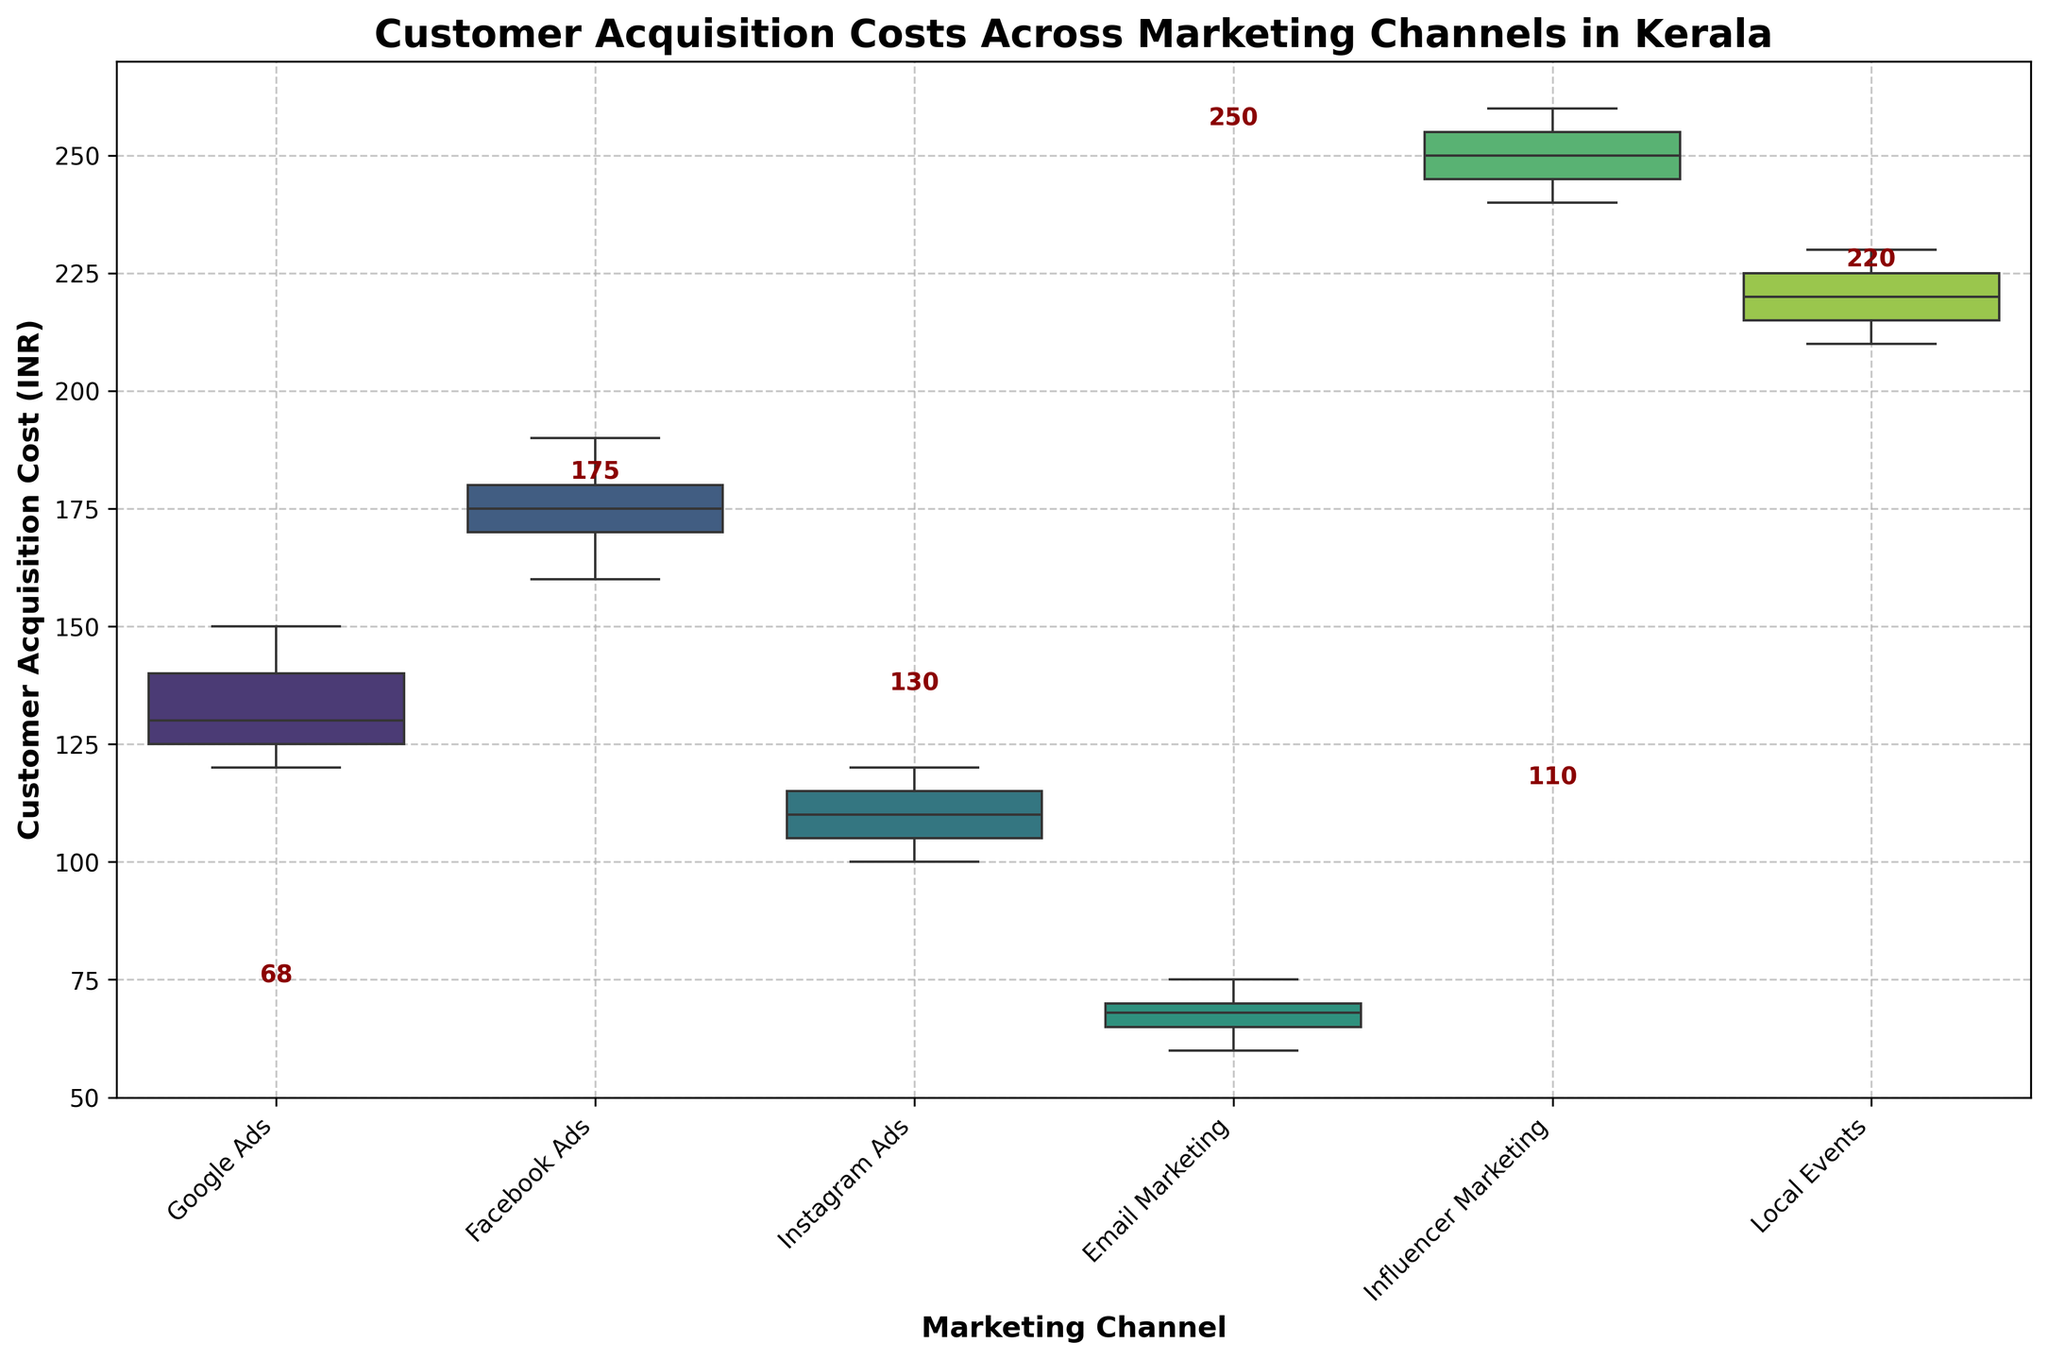Which marketing channel has the highest median customer acquisition cost? To determine the highest median customer acquisition cost, look at the median values displayed on top of each box plot for different marketing channels. Influencer Marketing has the highest median value.
Answer: Influencer Marketing What is the range of customer acquisition costs for Google Ads? The range can be found by looking at the minimum and maximum points of the box plot for Google Ads. The minimum value is 120 INR and the maximum value is 150 INR. Therefore, the range is 150 - 120 = 30 INR.
Answer: 30 INR Which marketing channel has the lowest median customer acquisition cost? The lowest median value is indicated on top of the box plots. Email Marketing has the lowest median value of 68 INR.
Answer: Email Marketing How does the spread of customer acquisition costs compare between Facebook Ads and Local Events? To compare the spread, look at the interquartile range (IQR), indicated by the width of the box in the box plot. Facebook Ads has a somewhat wider box, indicating a larger spread compared to Local Events.
Answer: Facebook Ads has a larger spread What is the interquartile range (IQR) for Instagram Ads? To find the IQR, subtract the lower quartile (25th percentile) from the upper quartile (75th percentile). For Instagram Ads, the lower quartile is 105 INR and the upper quartile is 115 INR. Therefore, the IQR is 115 - 105 = 10 INR.
Answer: 10 INR What is the median customer acquisition cost for Local Events, and how does it compare to that of Facebook Ads? The median values are displayed on top of the box plots. Local Events have a median value of 220 INR, and Facebook Ads have a median value of 180 INR. Therefore, Local Events have a higher median value compared to Facebook Ads.
Answer: Local Events' median is higher What is the difference between the maximum customer acquisition costs for Influencer Marketing and Email Marketing? Look at the whiskers (lines extending from the boxes) to find the maximum values. Influencer Marketing has a maximum of 260 INR and Email Marketing has a maximum of 75 INR. The difference is 260 - 75 = 185 INR.
Answer: 185 INR Which marketing channel shows the highest variability in customer acquisition costs? The highest variability is indicated by the largest span between the whiskers and the box. Influencer Marketing has the highest variability, with a wide spread compared to other channels.
Answer: Influencer Marketing Which marketing channel has the smallest interquartile range (IQR)? The smallest IQR is determined by the box plot with the narrowest box. Email Marketing has the smallest IQR, with a very narrow box.
Answer: Email Marketing 